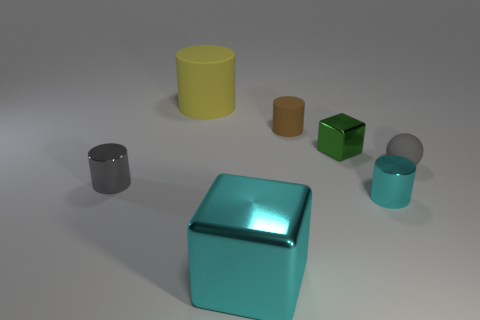Subtract all cyan metal cylinders. How many cylinders are left? 3 Subtract all cyan cylinders. How many cylinders are left? 3 Add 2 gray rubber things. How many objects exist? 9 Subtract all purple cylinders. Subtract all purple blocks. How many cylinders are left? 4 Subtract all spheres. How many objects are left? 6 Add 6 large cyan metal blocks. How many large cyan metal blocks exist? 7 Subtract 0 red cylinders. How many objects are left? 7 Subtract all gray rubber objects. Subtract all small gray matte spheres. How many objects are left? 5 Add 6 gray rubber objects. How many gray rubber objects are left? 7 